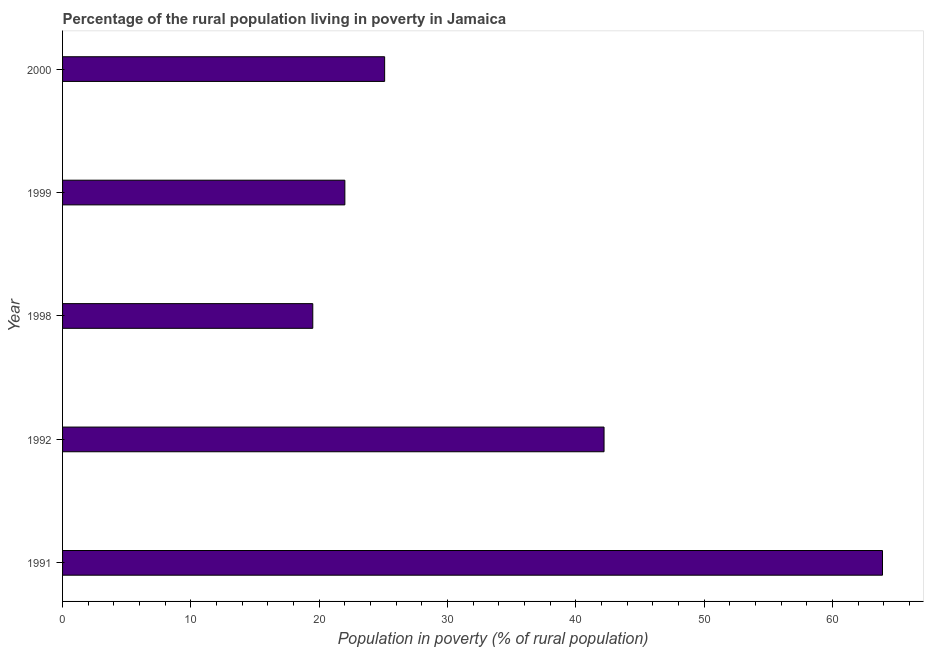Does the graph contain grids?
Offer a terse response. No. What is the title of the graph?
Offer a terse response. Percentage of the rural population living in poverty in Jamaica. What is the label or title of the X-axis?
Your response must be concise. Population in poverty (% of rural population). What is the label or title of the Y-axis?
Your answer should be compact. Year. What is the percentage of rural population living below poverty line in 1991?
Keep it short and to the point. 63.9. Across all years, what is the maximum percentage of rural population living below poverty line?
Provide a short and direct response. 63.9. Across all years, what is the minimum percentage of rural population living below poverty line?
Ensure brevity in your answer.  19.5. In which year was the percentage of rural population living below poverty line maximum?
Ensure brevity in your answer.  1991. What is the sum of the percentage of rural population living below poverty line?
Your response must be concise. 172.7. What is the difference between the percentage of rural population living below poverty line in 1991 and 1992?
Make the answer very short. 21.7. What is the average percentage of rural population living below poverty line per year?
Make the answer very short. 34.54. What is the median percentage of rural population living below poverty line?
Give a very brief answer. 25.1. In how many years, is the percentage of rural population living below poverty line greater than 44 %?
Offer a terse response. 1. What is the ratio of the percentage of rural population living below poverty line in 1991 to that in 1999?
Provide a short and direct response. 2.9. Is the difference between the percentage of rural population living below poverty line in 1991 and 1992 greater than the difference between any two years?
Give a very brief answer. No. What is the difference between the highest and the second highest percentage of rural population living below poverty line?
Offer a very short reply. 21.7. Is the sum of the percentage of rural population living below poverty line in 1991 and 1992 greater than the maximum percentage of rural population living below poverty line across all years?
Ensure brevity in your answer.  Yes. What is the difference between the highest and the lowest percentage of rural population living below poverty line?
Keep it short and to the point. 44.4. In how many years, is the percentage of rural population living below poverty line greater than the average percentage of rural population living below poverty line taken over all years?
Offer a terse response. 2. How many bars are there?
Keep it short and to the point. 5. Are all the bars in the graph horizontal?
Ensure brevity in your answer.  Yes. What is the difference between two consecutive major ticks on the X-axis?
Keep it short and to the point. 10. Are the values on the major ticks of X-axis written in scientific E-notation?
Offer a very short reply. No. What is the Population in poverty (% of rural population) in 1991?
Your response must be concise. 63.9. What is the Population in poverty (% of rural population) of 1992?
Offer a very short reply. 42.2. What is the Population in poverty (% of rural population) in 1999?
Ensure brevity in your answer.  22. What is the Population in poverty (% of rural population) of 2000?
Offer a terse response. 25.1. What is the difference between the Population in poverty (% of rural population) in 1991 and 1992?
Make the answer very short. 21.7. What is the difference between the Population in poverty (% of rural population) in 1991 and 1998?
Your response must be concise. 44.4. What is the difference between the Population in poverty (% of rural population) in 1991 and 1999?
Keep it short and to the point. 41.9. What is the difference between the Population in poverty (% of rural population) in 1991 and 2000?
Offer a very short reply. 38.8. What is the difference between the Population in poverty (% of rural population) in 1992 and 1998?
Ensure brevity in your answer.  22.7. What is the difference between the Population in poverty (% of rural population) in 1992 and 1999?
Provide a short and direct response. 20.2. What is the difference between the Population in poverty (% of rural population) in 1998 and 1999?
Keep it short and to the point. -2.5. What is the ratio of the Population in poverty (% of rural population) in 1991 to that in 1992?
Your answer should be compact. 1.51. What is the ratio of the Population in poverty (% of rural population) in 1991 to that in 1998?
Offer a very short reply. 3.28. What is the ratio of the Population in poverty (% of rural population) in 1991 to that in 1999?
Offer a very short reply. 2.9. What is the ratio of the Population in poverty (% of rural population) in 1991 to that in 2000?
Make the answer very short. 2.55. What is the ratio of the Population in poverty (% of rural population) in 1992 to that in 1998?
Your response must be concise. 2.16. What is the ratio of the Population in poverty (% of rural population) in 1992 to that in 1999?
Keep it short and to the point. 1.92. What is the ratio of the Population in poverty (% of rural population) in 1992 to that in 2000?
Your response must be concise. 1.68. What is the ratio of the Population in poverty (% of rural population) in 1998 to that in 1999?
Offer a very short reply. 0.89. What is the ratio of the Population in poverty (% of rural population) in 1998 to that in 2000?
Your answer should be very brief. 0.78. What is the ratio of the Population in poverty (% of rural population) in 1999 to that in 2000?
Make the answer very short. 0.88. 